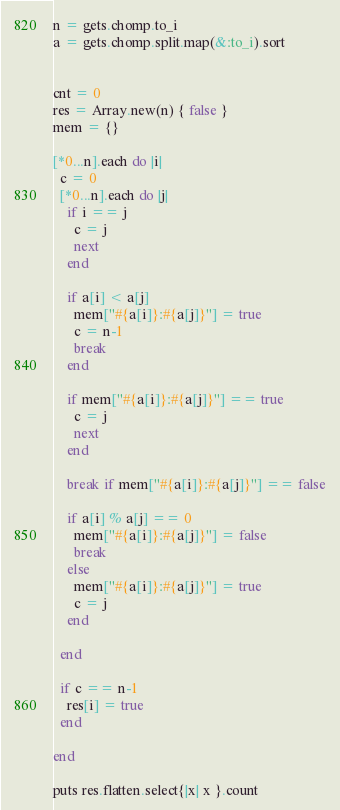<code> <loc_0><loc_0><loc_500><loc_500><_Ruby_>n = gets.chomp.to_i
a = gets.chomp.split.map(&:to_i).sort


cnt = 0
res = Array.new(n) { false }
mem = {}

[*0...n].each do |i|
  c = 0
  [*0...n].each do |j|
    if i == j
      c = j
      next
    end

    if a[i] < a[j]
      mem["#{a[i]}:#{a[j]}"] = true
      c = n-1
      break
    end

    if mem["#{a[i]}:#{a[j]}"] == true
      c = j
      next
    end

    break if mem["#{a[i]}:#{a[j]}"] == false

    if a[i] % a[j] == 0
      mem["#{a[i]}:#{a[j]}"] = false
      break
    else
      mem["#{a[i]}:#{a[j]}"] = true
      c = j
    end

  end

  if c == n-1
    res[i] = true
  end

end

puts res.flatten.select{|x| x }.count

</code> 